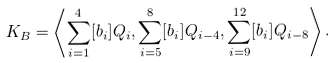<formula> <loc_0><loc_0><loc_500><loc_500>K _ { B } = \left \langle \sum _ { i = 1 } ^ { 4 } [ b _ { i } ] Q _ { i } , \sum _ { i = 5 } ^ { 8 } [ b _ { i } ] Q _ { i - 4 } , \sum _ { i = 9 } ^ { 1 2 } [ b _ { i } ] Q _ { i - 8 } \right \rangle .</formula> 